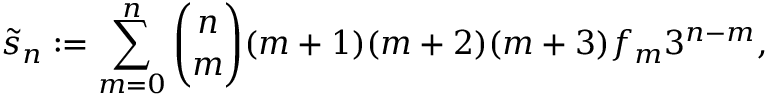<formula> <loc_0><loc_0><loc_500><loc_500>{ \widetilde { s } } _ { n } \colon = \sum _ { m = 0 } ^ { n } { \binom { n } { m } } ( m + 1 ) ( m + 2 ) ( m + 3 ) f _ { m } 3 ^ { n - m } ,</formula> 